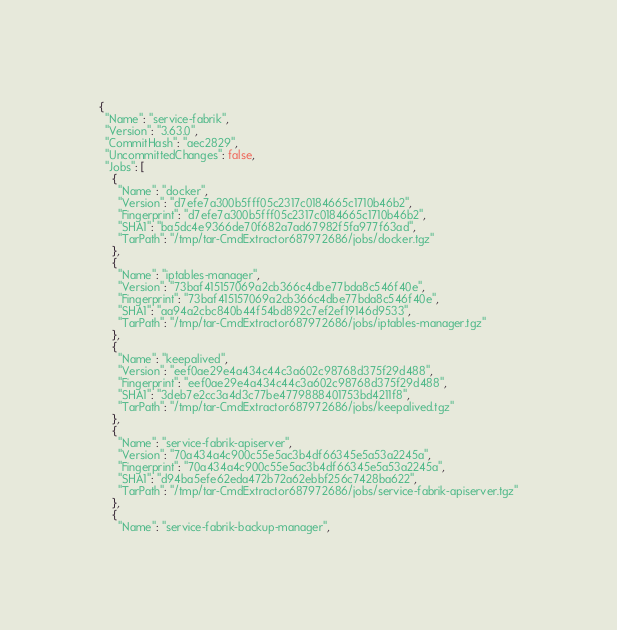Convert code to text. <code><loc_0><loc_0><loc_500><loc_500><_YAML_>{
  "Name": "service-fabrik",
  "Version": "3.63.0",
  "CommitHash": "aec2829",
  "UncommittedChanges": false,
  "Jobs": [
    {
      "Name": "docker",
      "Version": "d7efe7a300b5fff05c2317c0184665c1710b46b2",
      "Fingerprint": "d7efe7a300b5fff05c2317c0184665c1710b46b2",
      "SHA1": "ba5dc4e9366de70f682a7ad67982f5fa977f63ad",
      "TarPath": "/tmp/tar-CmdExtractor687972686/jobs/docker.tgz"
    },
    {
      "Name": "iptables-manager",
      "Version": "73baf415157069a2cb366c4dbe77bda8c546f40e",
      "Fingerprint": "73baf415157069a2cb366c4dbe77bda8c546f40e",
      "SHA1": "aa94a2cbc840b44f54bd892c7ef2ef19146d9533",
      "TarPath": "/tmp/tar-CmdExtractor687972686/jobs/iptables-manager.tgz"
    },
    {
      "Name": "keepalived",
      "Version": "eef0ae29e4a434c44c3a602c98768d375f29d488",
      "Fingerprint": "eef0ae29e4a434c44c3a602c98768d375f29d488",
      "SHA1": "3deb7e2cc3a4d3c77be4779888401753bd4211f8",
      "TarPath": "/tmp/tar-CmdExtractor687972686/jobs/keepalived.tgz"
    },
    {
      "Name": "service-fabrik-apiserver",
      "Version": "70a434a4c900c55e5ac3b4df66345e5a53a2245a",
      "Fingerprint": "70a434a4c900c55e5ac3b4df66345e5a53a2245a",
      "SHA1": "d94ba5efe62eda472b72a62ebbf256c7428ba622",
      "TarPath": "/tmp/tar-CmdExtractor687972686/jobs/service-fabrik-apiserver.tgz"
    },
    {
      "Name": "service-fabrik-backup-manager",</code> 